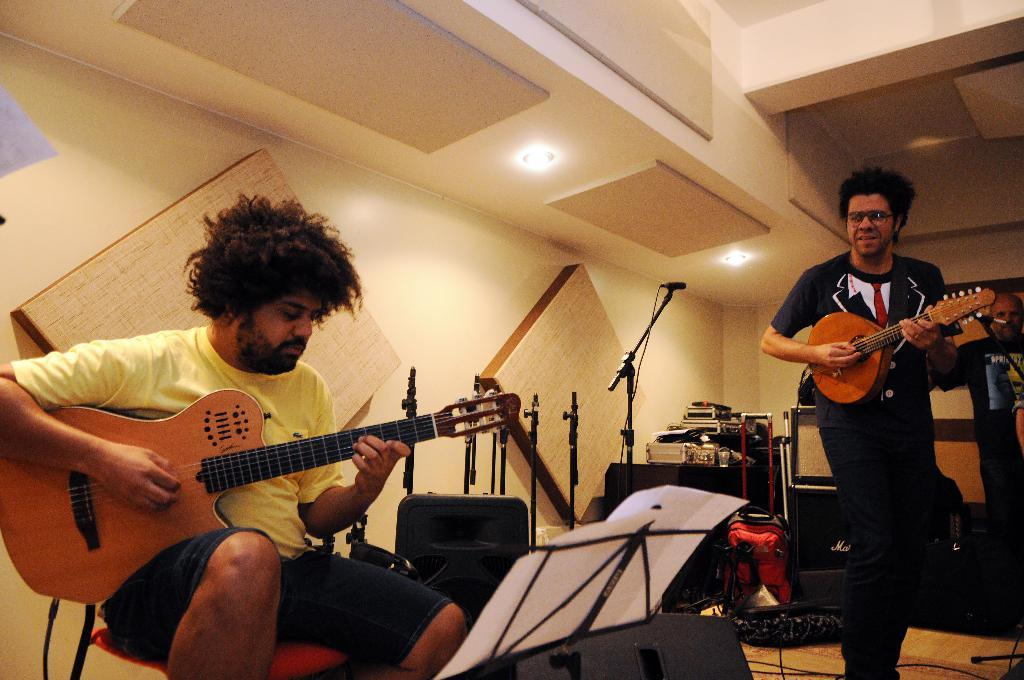How many people are in the image? There are two guys in the image. What are the guys doing in the image? The guys are playing a guitar. What other objects related to music can be seen in the image? There are musical instruments in the image. What might the guys be using to read the tunes for their music? There is a book with tunes in front of the guys. What can be seen in the background of the image? There are white and black boxes in the background of the image. What type of decision can be seen being made by the foot of the guy on the left in the image? There is no decision being made by the foot of the guy on the left in the image, as feet do not make decisions. 